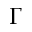Convert formula to latex. <formula><loc_0><loc_0><loc_500><loc_500>\Gamma</formula> 